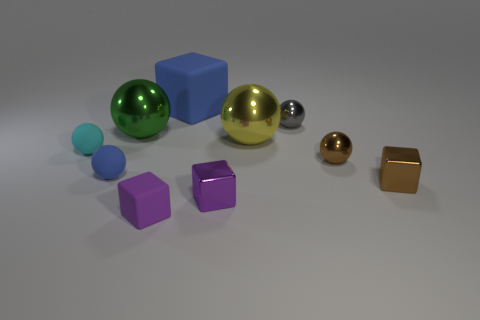Subtract all tiny spheres. How many spheres are left? 2 Subtract all brown balls. How many purple blocks are left? 2 Subtract 3 balls. How many balls are left? 3 Subtract all green balls. How many balls are left? 5 Subtract all green metal objects. Subtract all yellow metallic balls. How many objects are left? 8 Add 4 brown shiny balls. How many brown shiny balls are left? 5 Add 1 tiny brown blocks. How many tiny brown blocks exist? 2 Subtract 0 gray cubes. How many objects are left? 10 Subtract all balls. How many objects are left? 4 Subtract all green balls. Subtract all gray cubes. How many balls are left? 5 